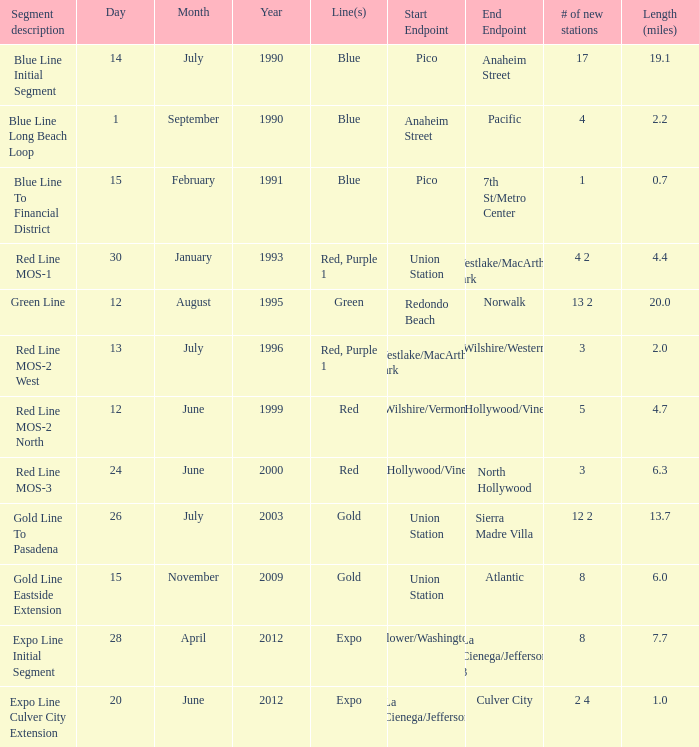How many lines have the segment description of red line mos-2 west? Red, Purple 1. 